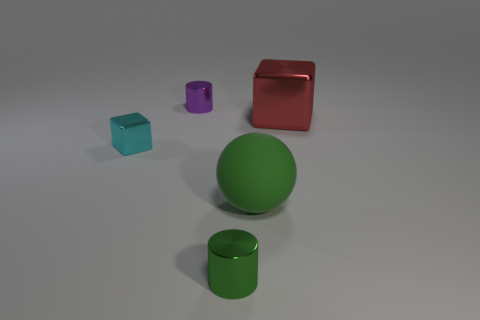Are there any tiny purple shiny objects of the same shape as the small green shiny object?
Provide a succinct answer. Yes. Does the tiny purple object have the same material as the big green thing that is in front of the purple shiny cylinder?
Your answer should be compact. No. What is the small object that is on the right side of the small cylinder that is on the left side of the green cylinder made of?
Offer a terse response. Metal. Are there more small purple cylinders that are left of the green ball than large green rubber cubes?
Give a very brief answer. Yes. Are there any large cyan metallic things?
Ensure brevity in your answer.  No. What color is the block right of the tiny green metal cylinder?
Give a very brief answer. Red. There is a block that is the same size as the green cylinder; what material is it?
Give a very brief answer. Metal. What number of other objects are the same material as the ball?
Ensure brevity in your answer.  0. There is a object that is both behind the tiny metallic cube and on the left side of the red metal thing; what is its color?
Keep it short and to the point. Purple. What number of things are tiny purple cylinders behind the red metallic thing or large red blocks?
Offer a terse response. 2. 